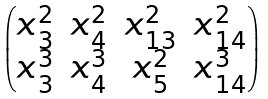Convert formula to latex. <formula><loc_0><loc_0><loc_500><loc_500>\begin{pmatrix} x _ { 3 } ^ { 2 } & x _ { 4 } ^ { 2 } & x _ { 1 3 } ^ { 2 } & x _ { 1 4 } ^ { 2 } \\ x _ { 3 } ^ { 3 } & x _ { 4 } ^ { 3 } & x _ { 5 } ^ { 2 } & x _ { 1 4 } ^ { 3 } \end{pmatrix}</formula> 